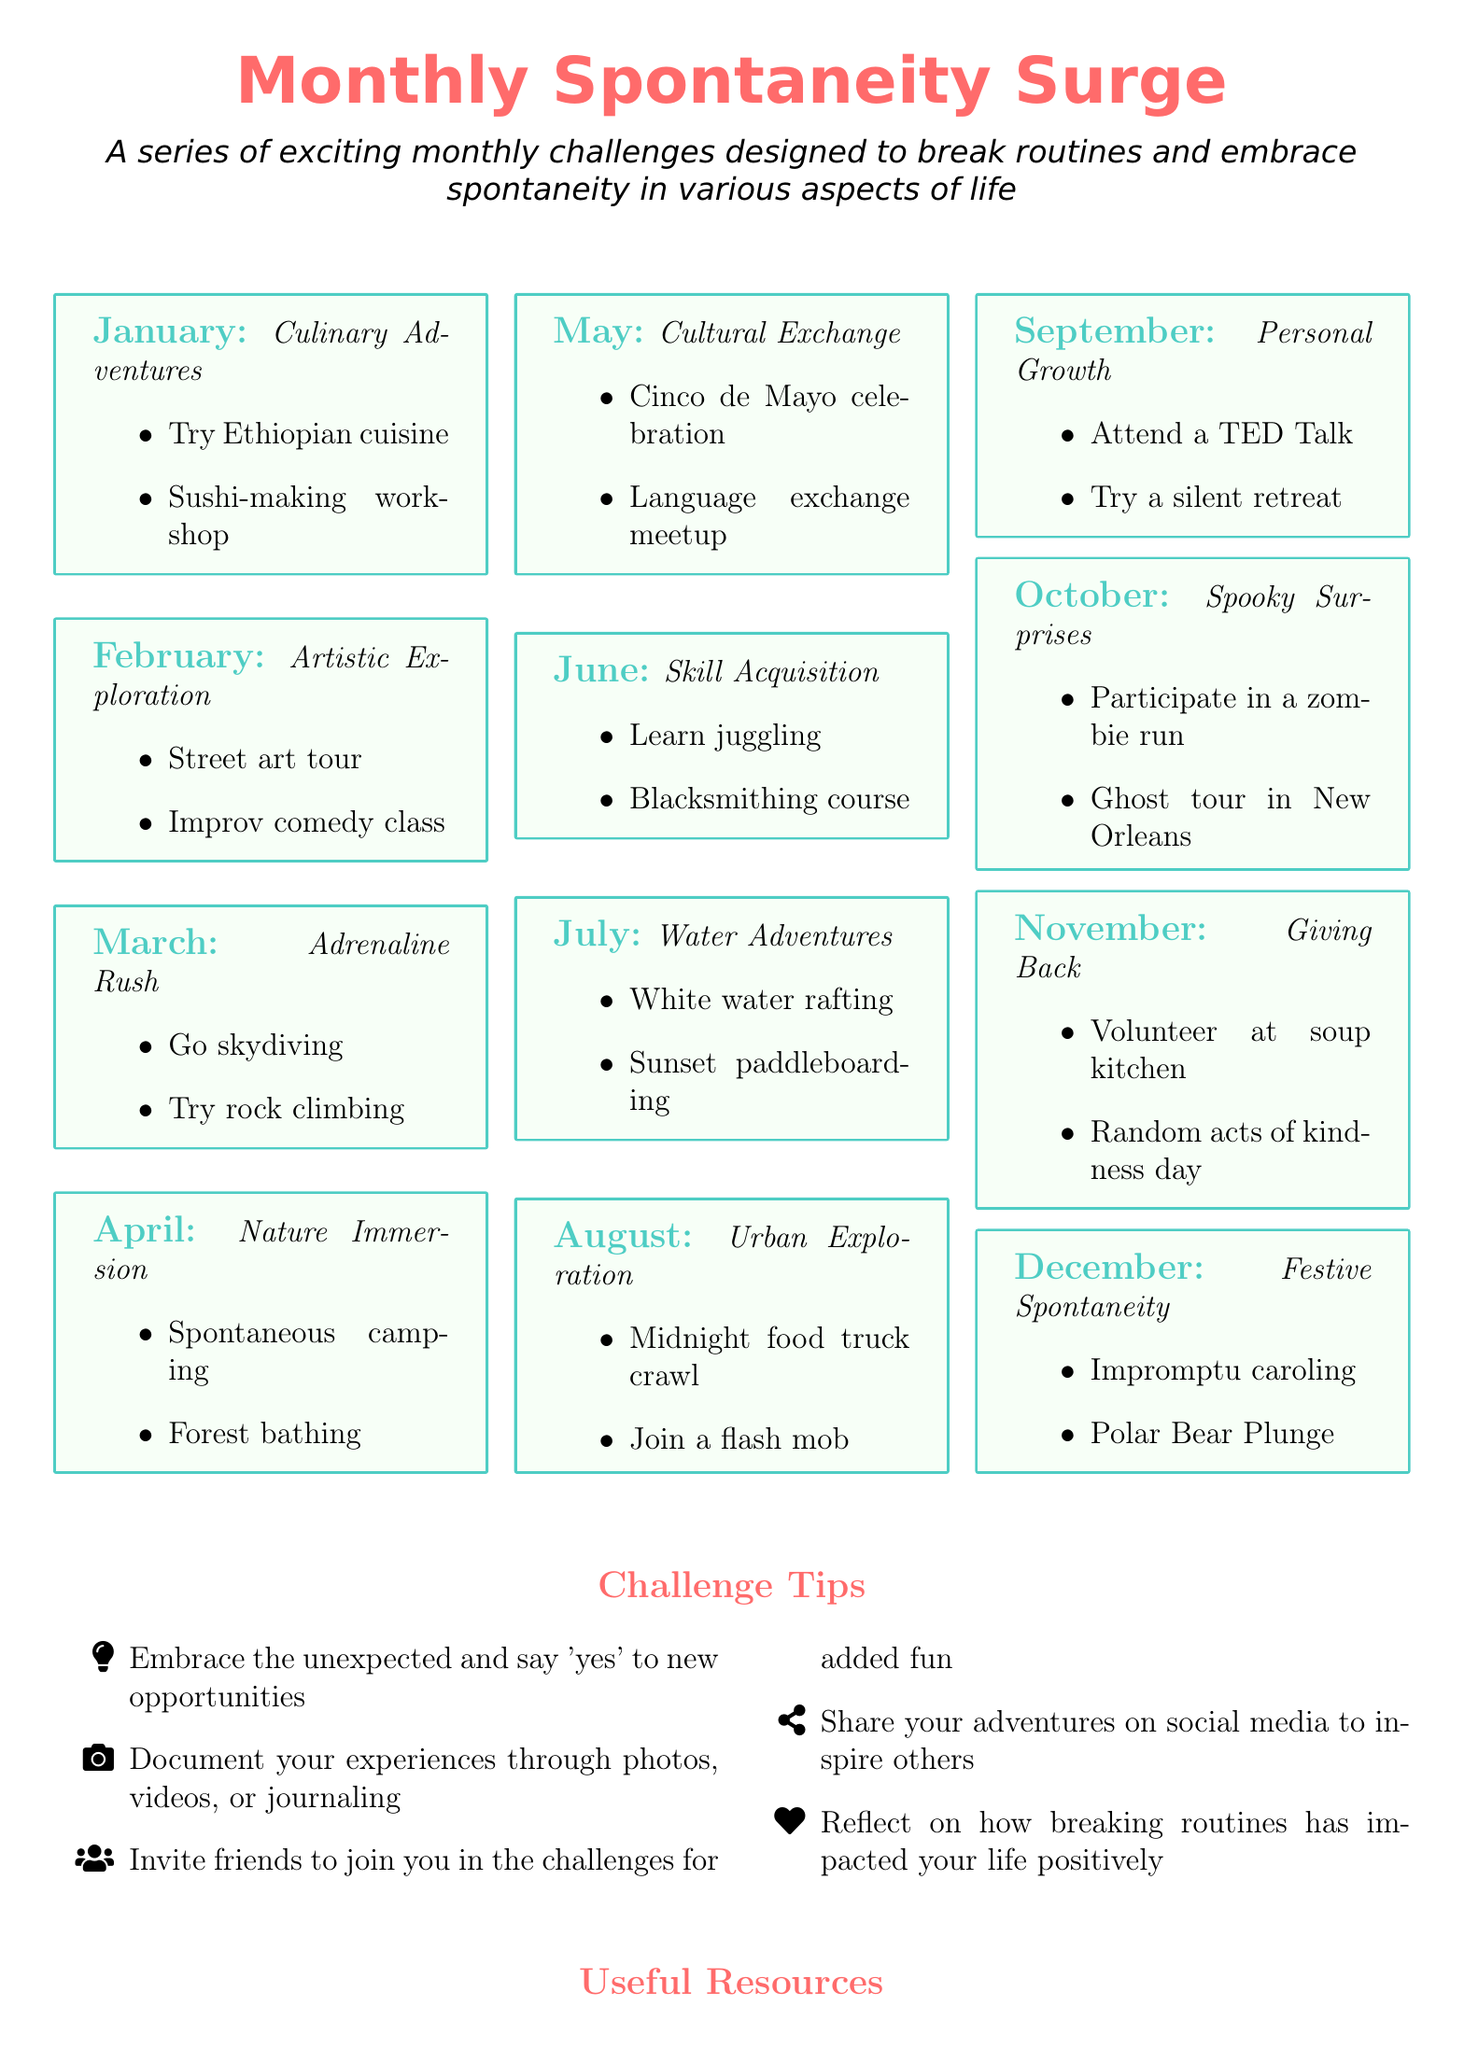What is the theme for May? The theme for May is specified in the document as "Cultural Exchange."
Answer: Cultural Exchange How many activities are suggested for each month? Each month lists four activities that are designed to fit the monthly theme.
Answer: Four What is one activity for January? The document includes several activities for January, such as trying Ethiopian cuisine or attending a sushi-making workshop.
Answer: Try Ethiopian cuisine Which month focuses on "Adrenaline Rush"? The month dedicated to "Adrenaline Rush" is clearly stated in the document as March.
Answer: March What is a tip for the challenge? The document offers various tips, one of which is to invite friends to join in the challenges for added fun.
Answer: Invite friends Name a resource mentioned for finding local events. The document lists "Meetup" as a resource for finding local groups and events connected to the monthly themes.
Answer: Meetup How many themes are outlined for the year? The document specifies themes for each month, totaling twelve themes throughout the year.
Answer: Twelve What activity is suggested for November? The document provides activities for November, such as volunteering at a soup kitchen on Thanksgiving.
Answer: Volunteer at a soup kitchen What type of document is this? The structure and content of the document make it clear that it is an agenda for a monthly challenge program.
Answer: Agenda 